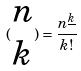<formula> <loc_0><loc_0><loc_500><loc_500>( \begin{matrix} n \\ k \end{matrix} ) = \frac { n ^ { \underline { k } } } { k ! }</formula> 